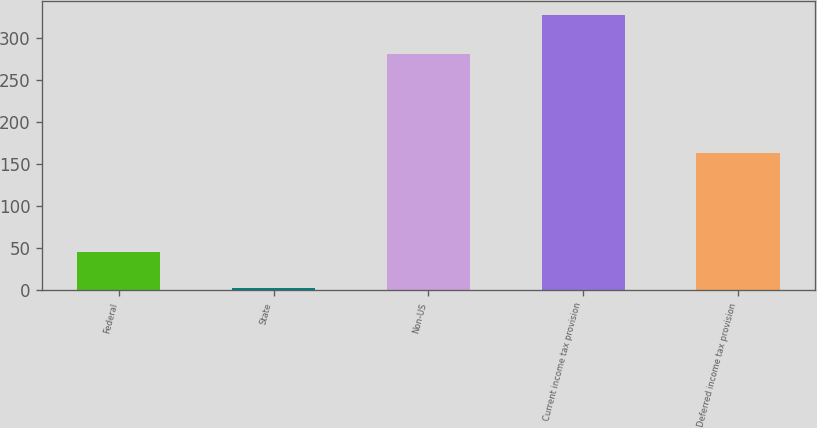Convert chart. <chart><loc_0><loc_0><loc_500><loc_500><bar_chart><fcel>Federal<fcel>State<fcel>Non-US<fcel>Current income tax provision<fcel>Deferred income tax provision<nl><fcel>45<fcel>2<fcel>281<fcel>328<fcel>163<nl></chart> 